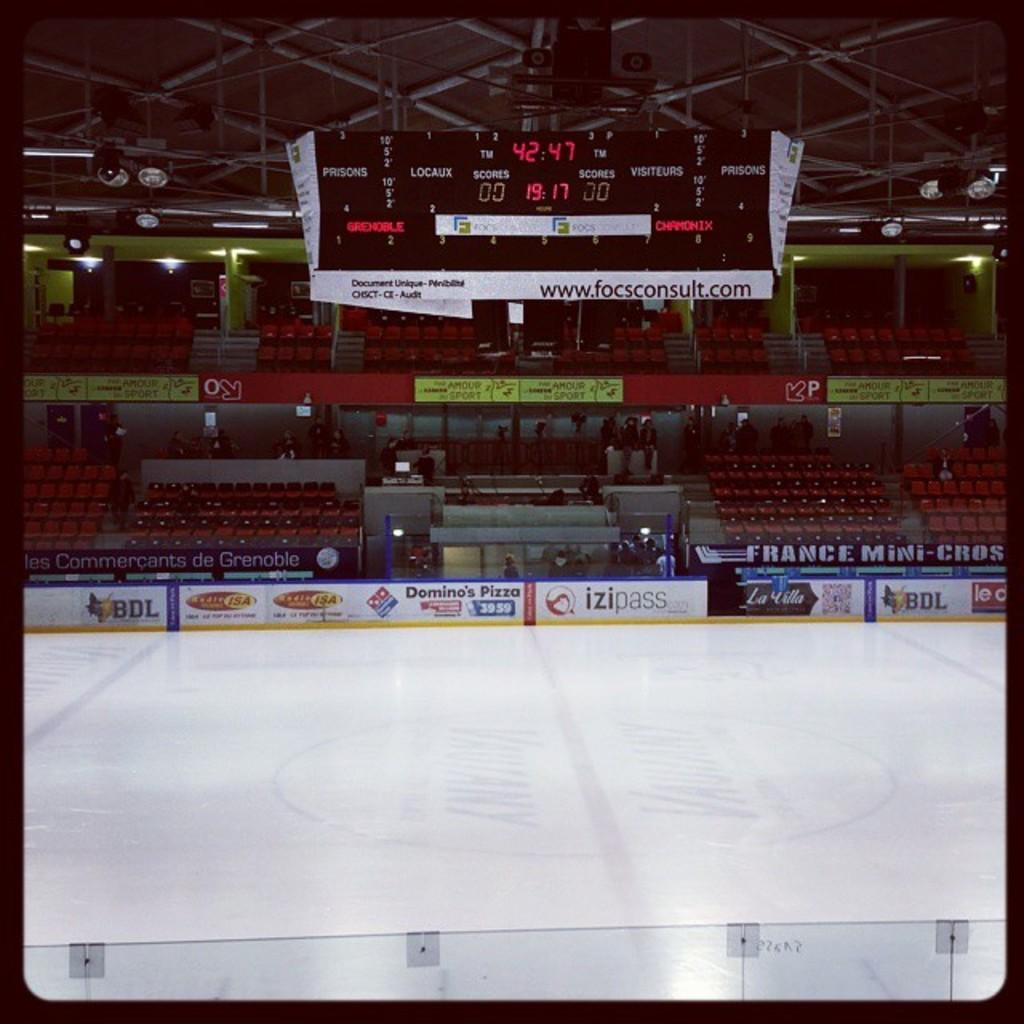<image>
Render a clear and concise summary of the photo. A hockey stadium with the time 42:47 and 19:17 that promotes Izipass. 